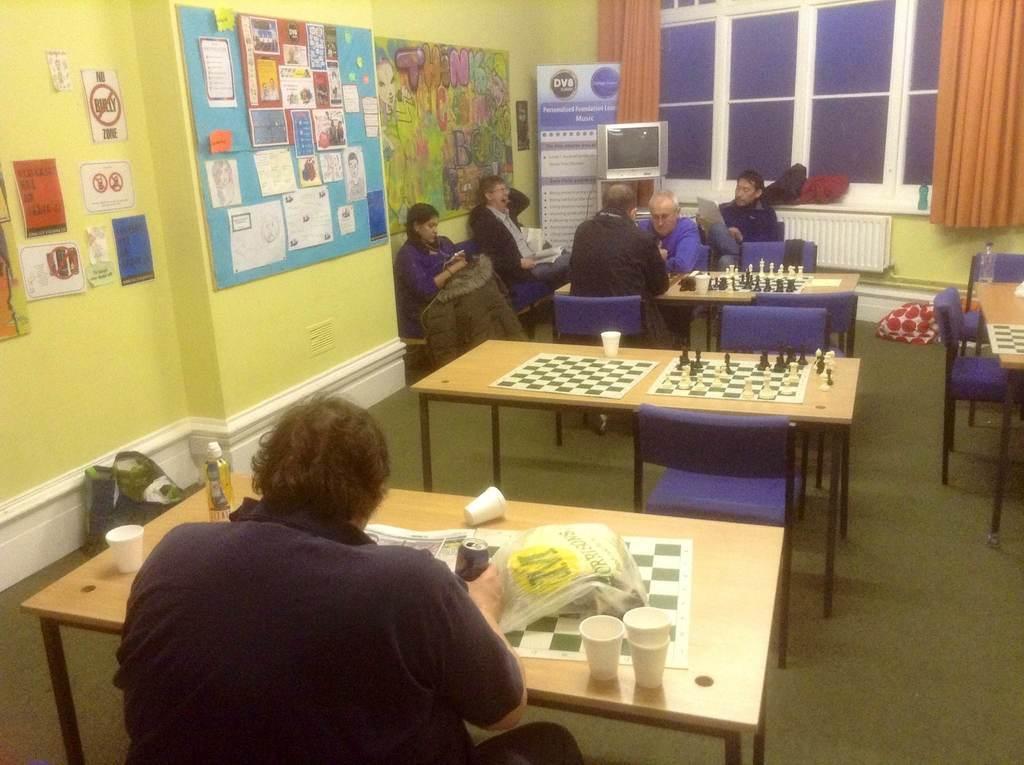Can you describe this image briefly? It is a room there are lot of tables people are playing chess on the table,to the left side there is a wall on which a lot of posters are there behind them there is a television in the background there is a wall and curtains. 